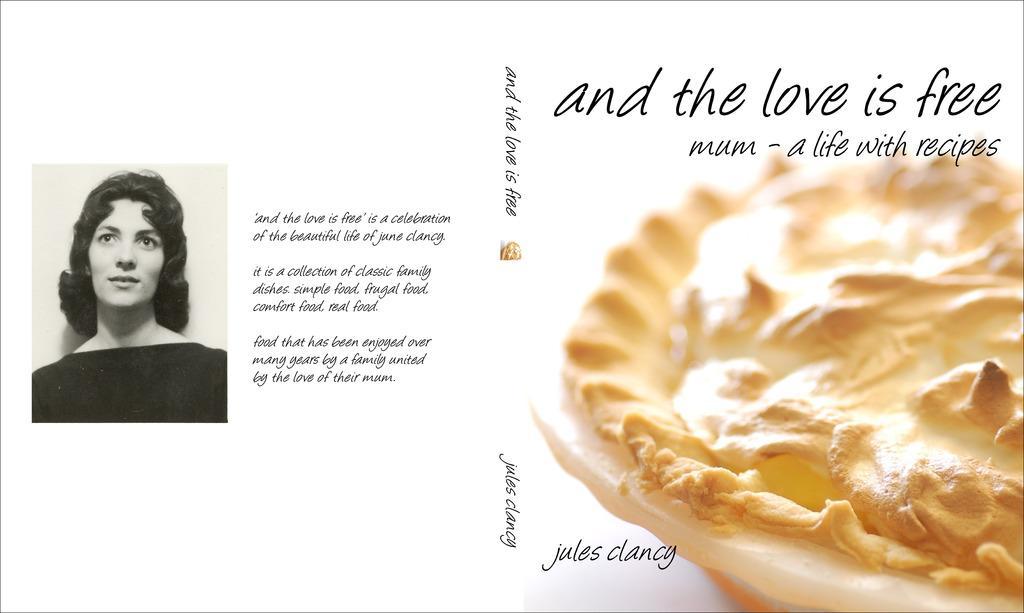How would you summarize this image in a sentence or two? In this picture there is a poster in the image, on which there is a photo of a lady, on the left side of the image and there is a bowl on the right side of the image, on the poster. 